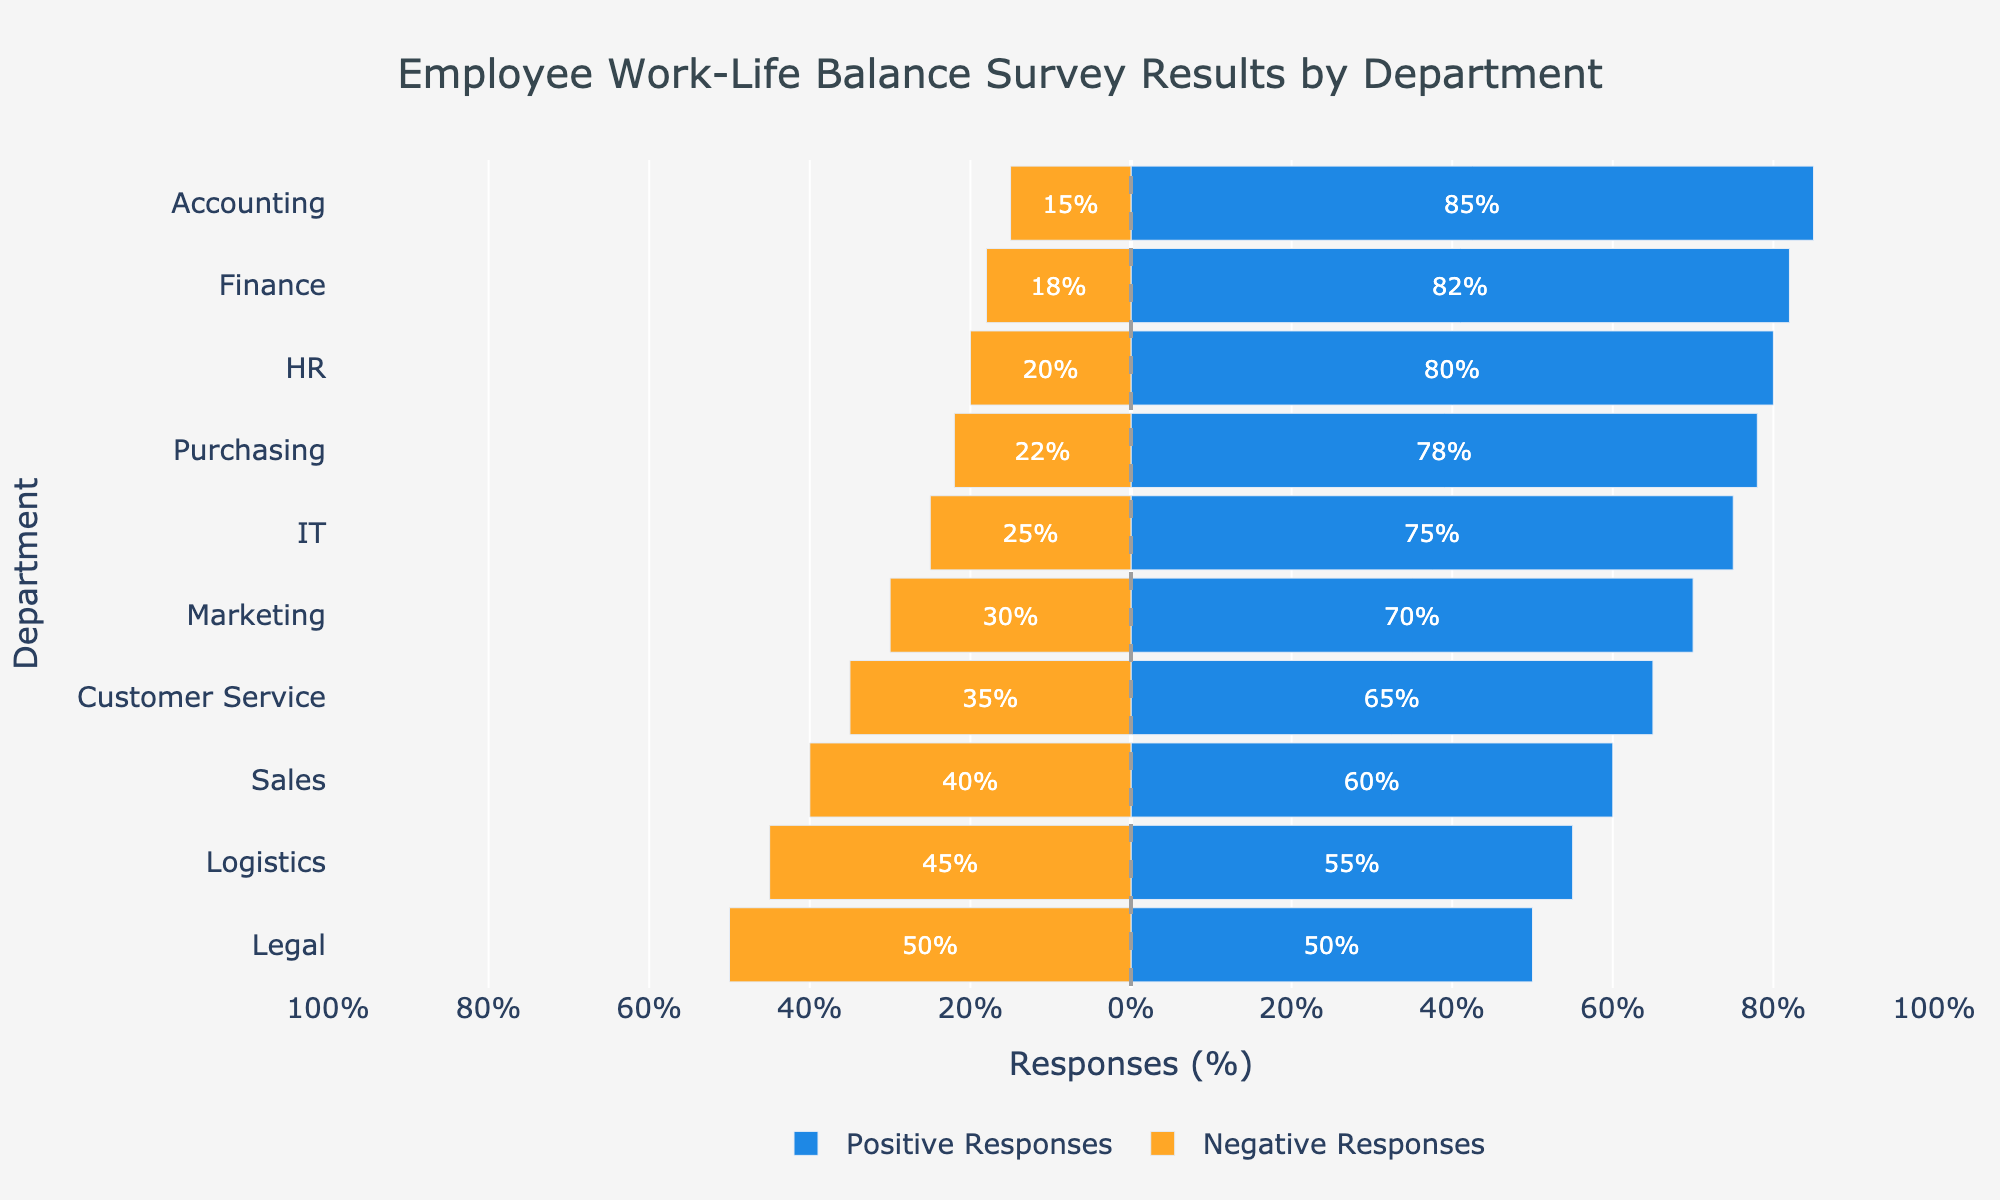Which department has the highest percentage of positive responses? Look at the bar with the longest positive value. The 'Finance' department has the highest percentage of positive responses, as indicated by its longer blue bar compared to others.
Answer: Finance Which department has an equal percentage of positive and negative responses? Identify the departments that have bars of equal length in both directions. The 'Legal' department has equal lengths of positive (blue) and negative (orange) bars (50% each).
Answer: Legal What is the total percentage of responses (positive + negative) for the HR department? The HR department has 80% positive responses and 20% negative responses. Summing them gives 80% + 20% = 100%.
Answer: 100% How many departments have more positive responses than negative responses? Count the number of departments where the blue bar (positive) is longer than the orange bar (negative). 
The departments are Accounting, Marketing, HR, IT, Customer Service, Purchasing, and Finance. Thus, there are 7 departments in total.
Answer: 7 Which department has the lowest percentage of positive responses? Look at the bar chart to find the department with the shortest blue bar representing positive responses. The 'Legal' department has the lowest percentage of positive responses (50%).
Answer: Legal What is the difference between the highest and lowest percentages of positive responses? The highest percentage of positive responses is in the 'Finance' department (82%), and the lowest is in the 'Legal' department (50%). The difference is 82% - 50% = 32%.
Answer: 32% In which department is the percentage of negative responses closest to 25%? Look for the department whose orange bar representing negative responses is closest to 25%. The 'IT' department has a negative response percentage exactly at 25%.
Answer: IT Compare the positive responses of the Marketing and Customer Service departments. The Marketing department has 70% positive responses, while the Customer Service department has 65% positive responses. Therefore, the Marketing department has a higher percentage of positive responses.
Answer: Marketing Which bar color represents the negative responses, and how can you identify it visually? Negative responses are represented by the orange bars. You can identify these by their color and the negative direction they extend on the chart.
Answer: Orange 